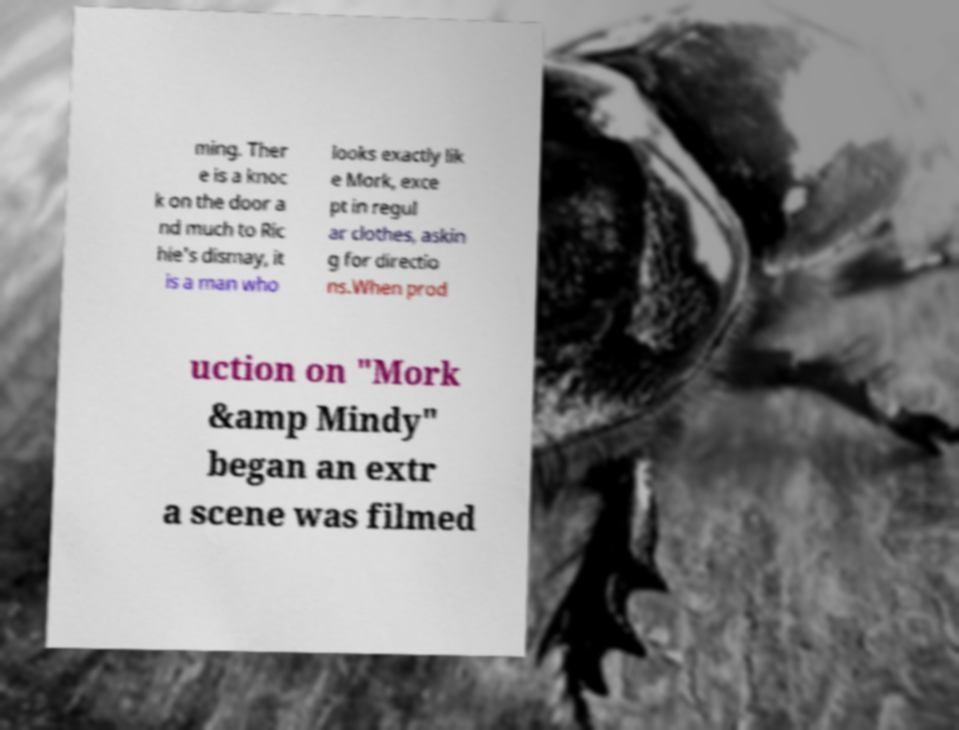I need the written content from this picture converted into text. Can you do that? ming. Ther e is a knoc k on the door a nd much to Ric hie's dismay, it is a man who looks exactly lik e Mork, exce pt in regul ar clothes, askin g for directio ns.When prod uction on "Mork &amp Mindy" began an extr a scene was filmed 